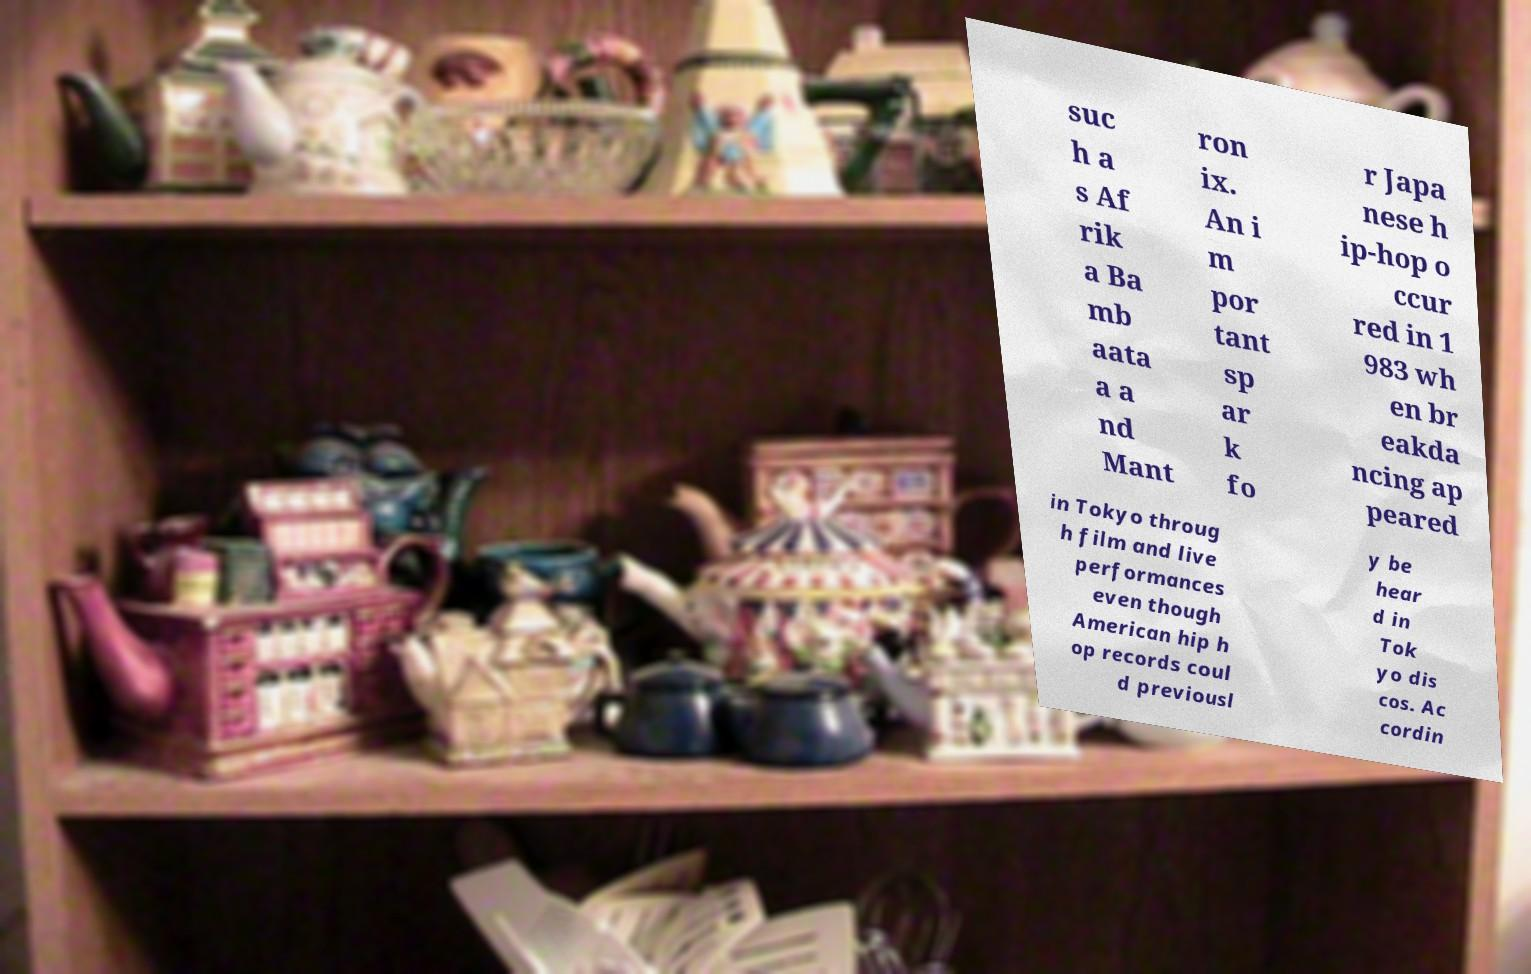Could you assist in decoding the text presented in this image and type it out clearly? suc h a s Af rik a Ba mb aata a a nd Mant ron ix. An i m por tant sp ar k fo r Japa nese h ip-hop o ccur red in 1 983 wh en br eakda ncing ap peared in Tokyo throug h film and live performances even though American hip h op records coul d previousl y be hear d in Tok yo dis cos. Ac cordin 